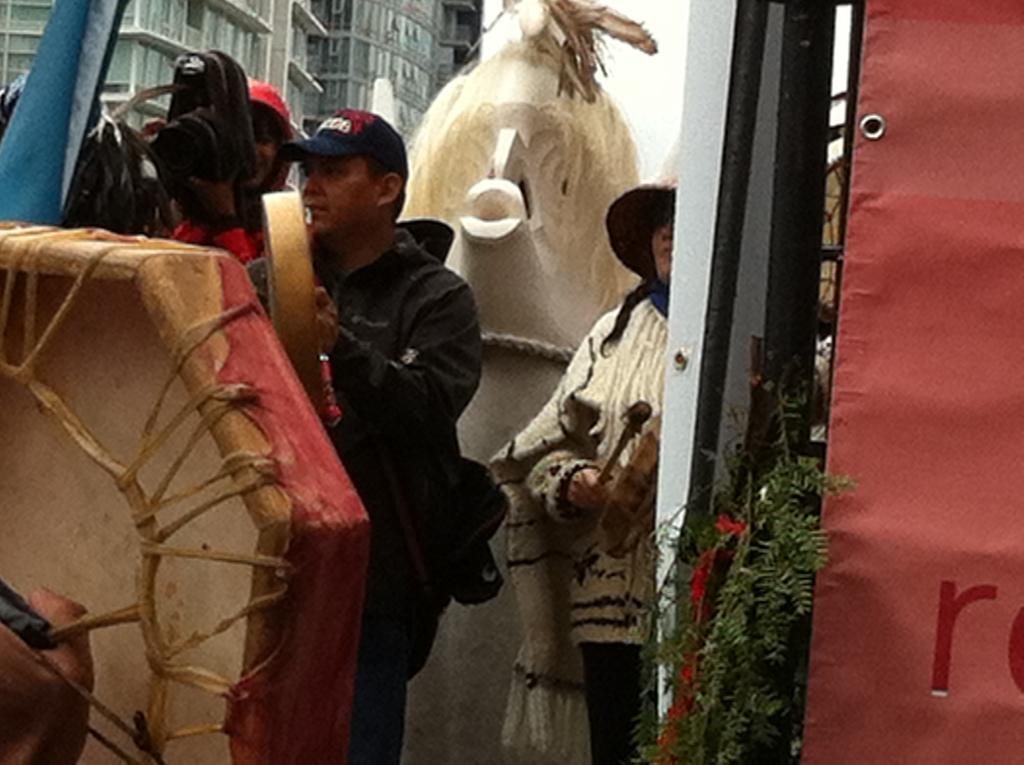Describe this image in one or two sentences. In this image I can see a man wearing black color shirt and cap on his head. In the background I can see a building. On the right side of the image there is a red color board. Just at the back of the man there is a woman. 